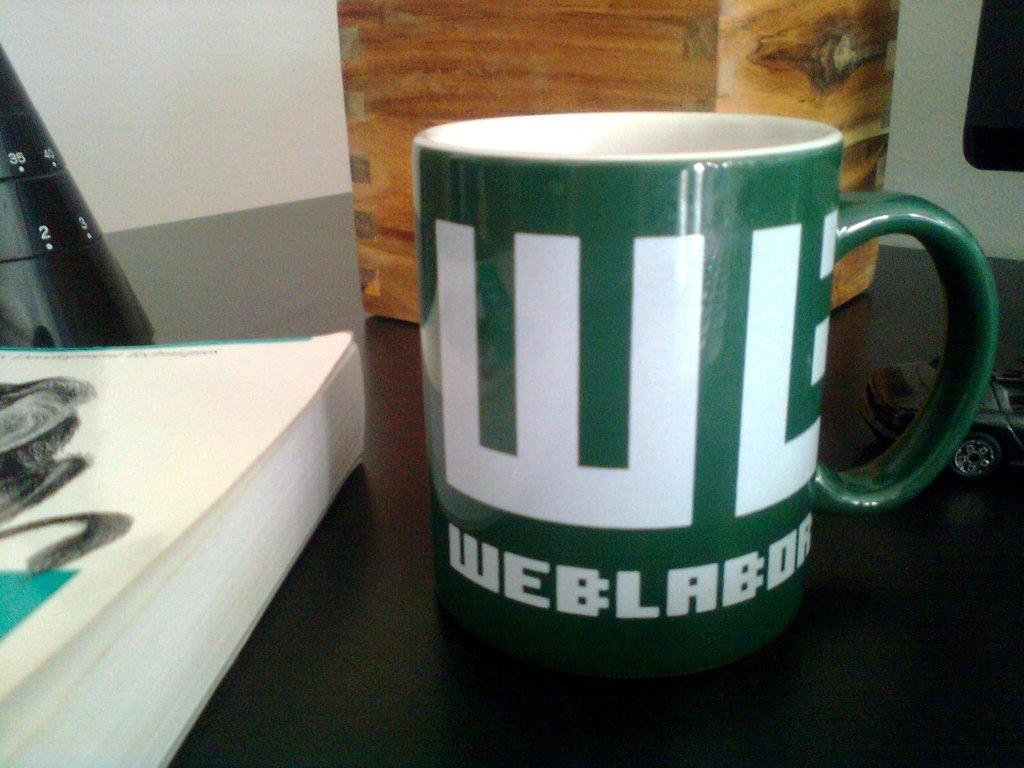<image>
Provide a brief description of the given image. A green coffee mug with the initials WB printed in bold. 